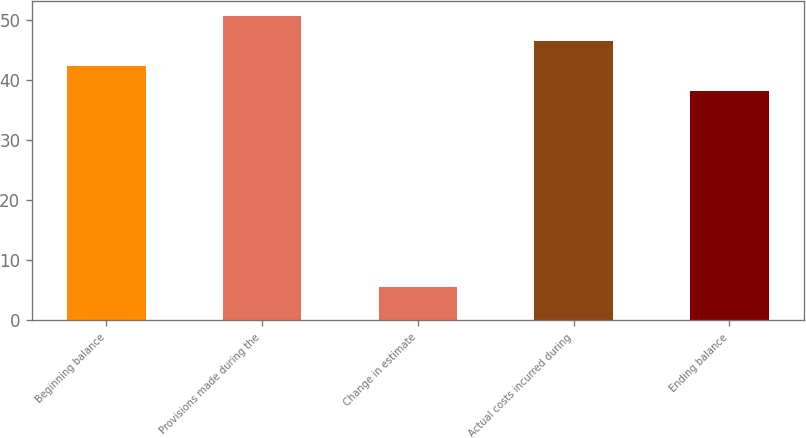<chart> <loc_0><loc_0><loc_500><loc_500><bar_chart><fcel>Beginning balance<fcel>Provisions made during the<fcel>Change in estimate<fcel>Actual costs incurred during<fcel>Ending balance<nl><fcel>42.33<fcel>50.59<fcel>5.6<fcel>46.46<fcel>38.2<nl></chart> 